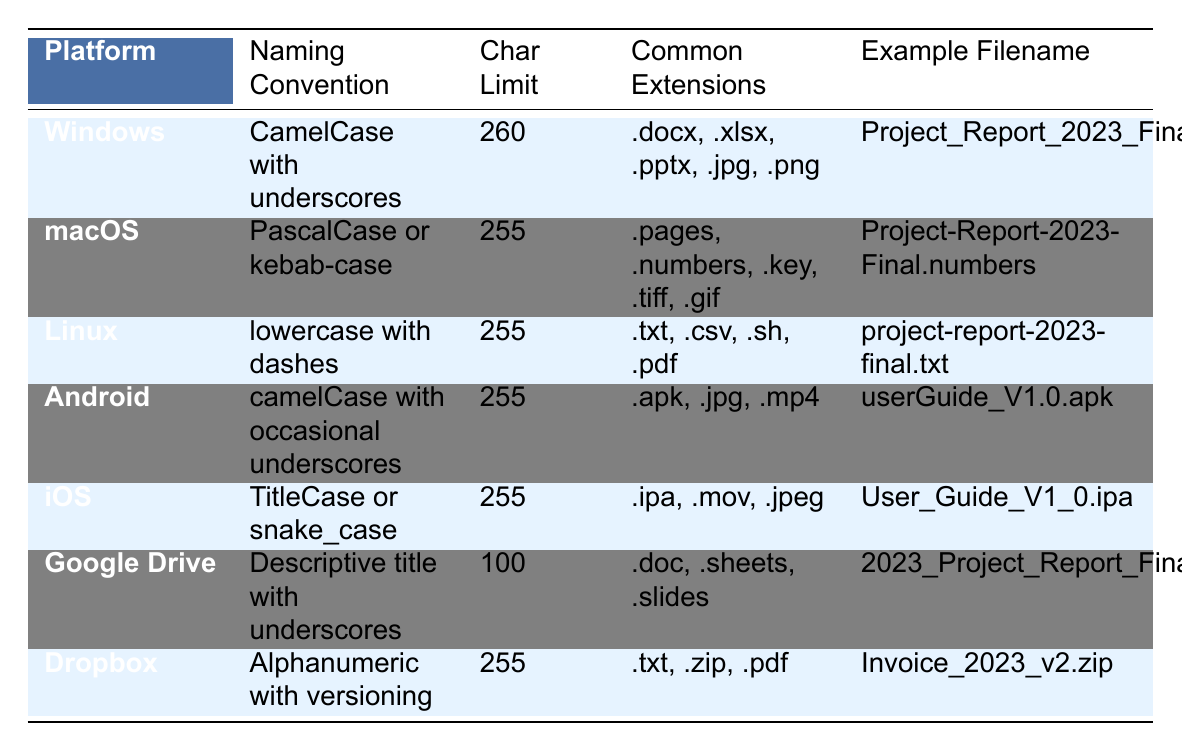What is the character limit for Windows file names? The table lists the character limit for Windows under the "Char Limit" column, which shows that it is 260 characters.
Answer: 260 What naming convention is used for Linux file names? Referring to the "Naming Convention" column of the Linux row, it states that the convention is "lowercase with dashes."
Answer: lowercase with dashes Which platform has the highest character limit for file names? Upon checking the "Char Limit" column, Windows has a limit of 260 characters, which is higher than Linux, macOS, Android, iOS, Google Drive, and Dropbox.
Answer: Windows Is "Invoice_2023_v2.zip" a valid example filename for Dropbox? Yes, the filename matches the "Example Filename" listed under the Dropbox row, confirming it as valid.
Answer: Yes What is the common file extension for Android? According to the "Common Extensions" column for Android, the extensions are ".apk, .jpg, .mp4."
Answer: .apk, .jpg, .mp4 Compare the naming convention for iOS and macOS. How are they different? The iOS naming convention is "TitleCase or snake_case," while for macOS it is "PascalCase or kebab-case," indicating different formatting styles (e.g., underscores versus hyphens).
Answer: Different formatting styles How many different common file extensions are listed for Google Drive? The "Common Extensions" column under Google Drive lists three extensions: .doc, .sheets, .slides, which means there are three extensions total.
Answer: 3 Which platform uses underscores in its naming convention? Looking through the table, both Windows and Google Drive use underscores in their naming conventions.
Answer: Windows and Google Drive What is the average character limit across all platforms listed? Summing the character limits for the platforms: 260 + 255 + 255 + 255 + 255 + 100 + 255 = 1,585. Then dividing by the number of platforms (7), the average character limit is 1,585 / 7 ≈ 226.43.
Answer: 226.43 True or False: The naming convention for Google Drive allows for uppercase letters. The naming convention for Google Drive is "Descriptive title with underscores," which allows for uppercase letters since no specific case is specified.
Answer: True Which platform has the least character limit for filenames? The table shows Google Drive having the least character limit of 100 characters.
Answer: Google Drive 